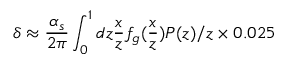<formula> <loc_0><loc_0><loc_500><loc_500>\delta \approx \frac { \alpha _ { s } } { 2 \pi } \int _ { 0 } ^ { 1 } d z \frac { x } { z } f _ { g } ( \frac { x } { z } ) P ( z ) / z \times 0 . 0 2 5</formula> 